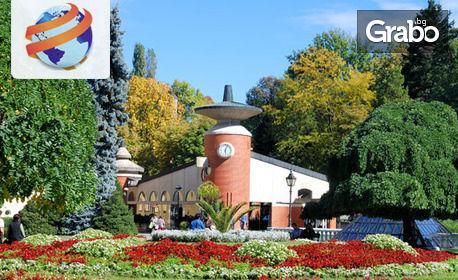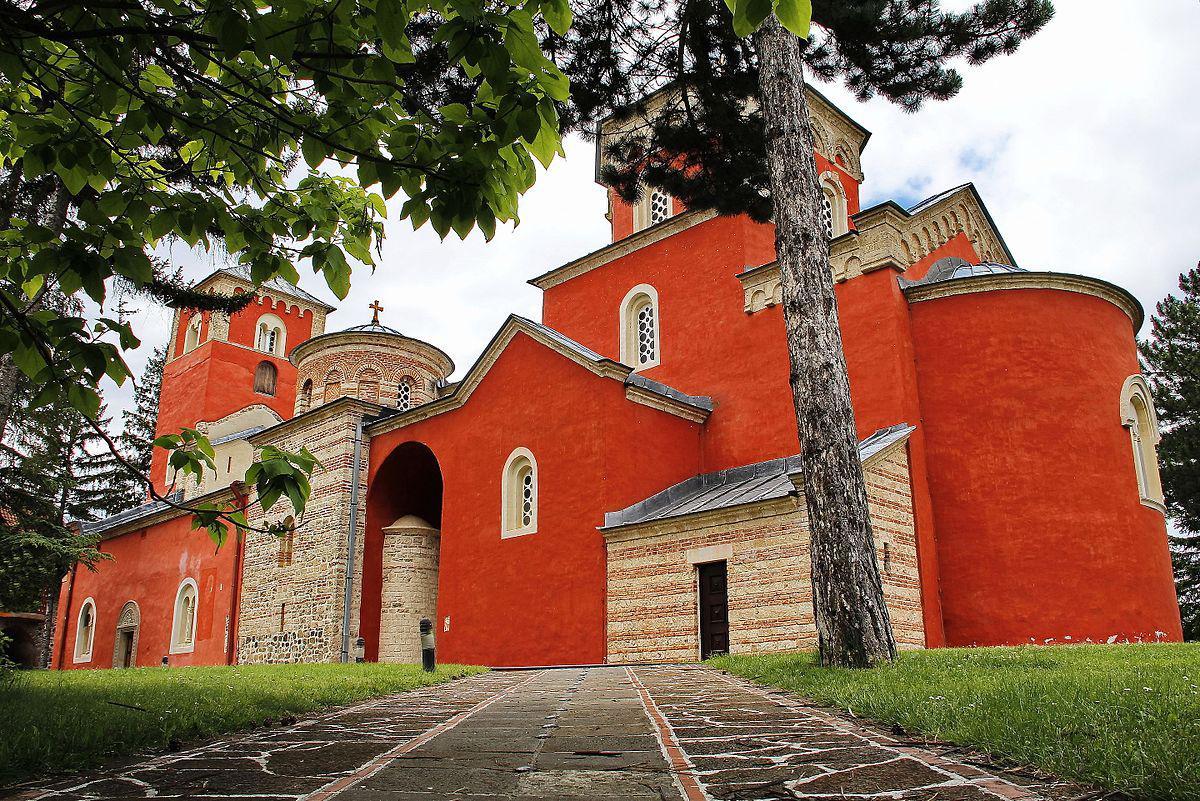The first image is the image on the left, the second image is the image on the right. For the images shown, is this caption "At least one of the buildings in the image on the left is bright orange." true? Answer yes or no. No. The first image is the image on the left, the second image is the image on the right. Analyze the images presented: Is the assertion "Left image shows a reddish-orange building with a dome-topped tower with flat sides featuring round-topped windows." valid? Answer yes or no. No. 